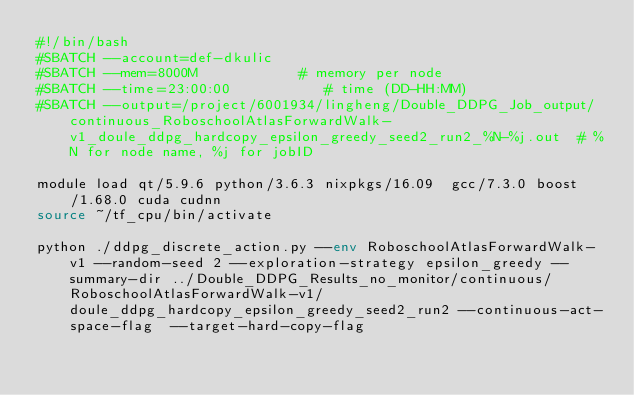<code> <loc_0><loc_0><loc_500><loc_500><_Bash_>#!/bin/bash
#SBATCH --account=def-dkulic
#SBATCH --mem=8000M            # memory per node
#SBATCH --time=23:00:00           # time (DD-HH:MM)
#SBATCH --output=/project/6001934/lingheng/Double_DDPG_Job_output/continuous_RoboschoolAtlasForwardWalk-v1_doule_ddpg_hardcopy_epsilon_greedy_seed2_run2_%N-%j.out  # %N for node name, %j for jobID

module load qt/5.9.6 python/3.6.3 nixpkgs/16.09  gcc/7.3.0 boost/1.68.0 cuda cudnn
source ~/tf_cpu/bin/activate

python ./ddpg_discrete_action.py --env RoboschoolAtlasForwardWalk-v1 --random-seed 2 --exploration-strategy epsilon_greedy --summary-dir ../Double_DDPG_Results_no_monitor/continuous/RoboschoolAtlasForwardWalk-v1/doule_ddpg_hardcopy_epsilon_greedy_seed2_run2 --continuous-act-space-flag  --target-hard-copy-flag 

</code> 